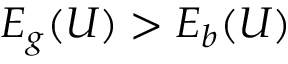<formula> <loc_0><loc_0><loc_500><loc_500>E _ { g } ( U ) > E _ { b } ( U )</formula> 